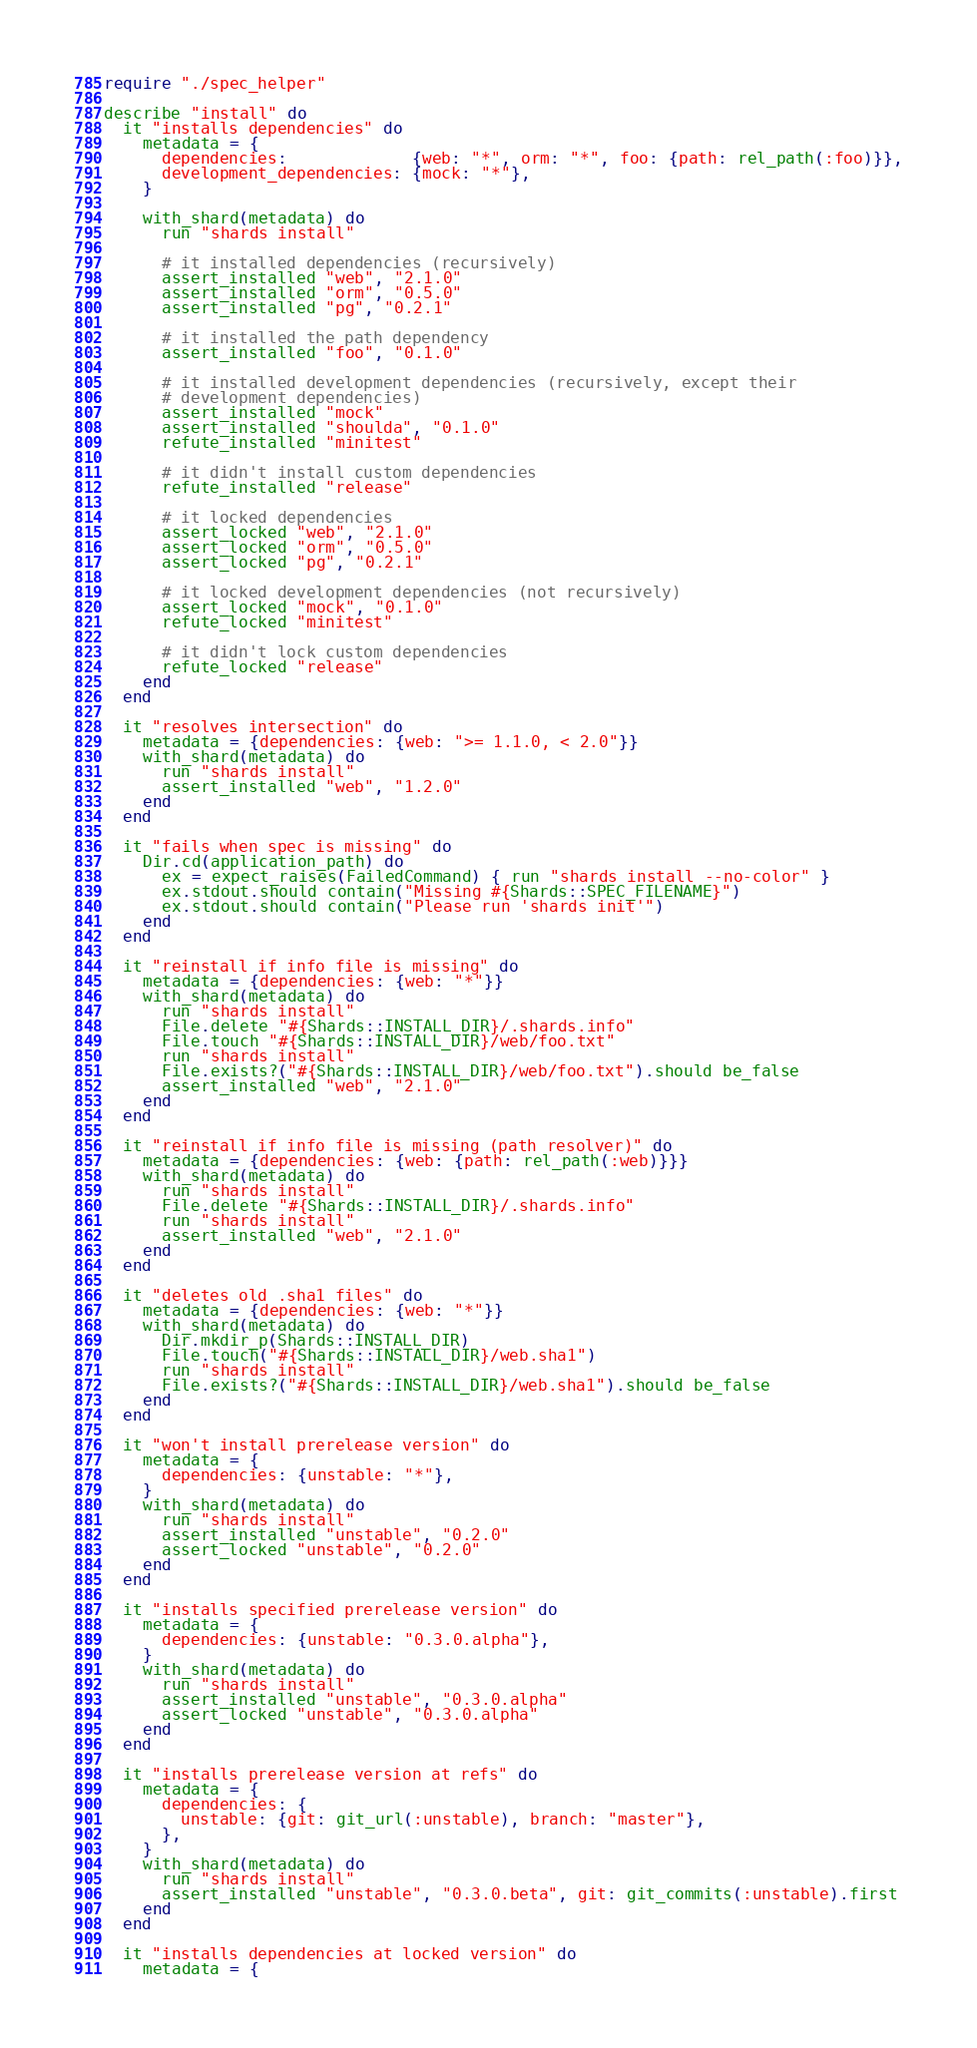<code> <loc_0><loc_0><loc_500><loc_500><_Crystal_>require "./spec_helper"

describe "install" do
  it "installs dependencies" do
    metadata = {
      dependencies:             {web: "*", orm: "*", foo: {path: rel_path(:foo)}},
      development_dependencies: {mock: "*"},
    }

    with_shard(metadata) do
      run "shards install"

      # it installed dependencies (recursively)
      assert_installed "web", "2.1.0"
      assert_installed "orm", "0.5.0"
      assert_installed "pg", "0.2.1"

      # it installed the path dependency
      assert_installed "foo", "0.1.0"

      # it installed development dependencies (recursively, except their
      # development dependencies)
      assert_installed "mock"
      assert_installed "shoulda", "0.1.0"
      refute_installed "minitest"

      # it didn't install custom dependencies
      refute_installed "release"

      # it locked dependencies
      assert_locked "web", "2.1.0"
      assert_locked "orm", "0.5.0"
      assert_locked "pg", "0.2.1"

      # it locked development dependencies (not recursively)
      assert_locked "mock", "0.1.0"
      refute_locked "minitest"

      # it didn't lock custom dependencies
      refute_locked "release"
    end
  end

  it "resolves intersection" do
    metadata = {dependencies: {web: ">= 1.1.0, < 2.0"}}
    with_shard(metadata) do
      run "shards install"
      assert_installed "web", "1.2.0"
    end
  end

  it "fails when spec is missing" do
    Dir.cd(application_path) do
      ex = expect_raises(FailedCommand) { run "shards install --no-color" }
      ex.stdout.should contain("Missing #{Shards::SPEC_FILENAME}")
      ex.stdout.should contain("Please run 'shards init'")
    end
  end

  it "reinstall if info file is missing" do
    metadata = {dependencies: {web: "*"}}
    with_shard(metadata) do
      run "shards install"
      File.delete "#{Shards::INSTALL_DIR}/.shards.info"
      File.touch "#{Shards::INSTALL_DIR}/web/foo.txt"
      run "shards install"
      File.exists?("#{Shards::INSTALL_DIR}/web/foo.txt").should be_false
      assert_installed "web", "2.1.0"
    end
  end

  it "reinstall if info file is missing (path resolver)" do
    metadata = {dependencies: {web: {path: rel_path(:web)}}}
    with_shard(metadata) do
      run "shards install"
      File.delete "#{Shards::INSTALL_DIR}/.shards.info"
      run "shards install"
      assert_installed "web", "2.1.0"
    end
  end

  it "deletes old .sha1 files" do
    metadata = {dependencies: {web: "*"}}
    with_shard(metadata) do
      Dir.mkdir_p(Shards::INSTALL_DIR)
      File.touch("#{Shards::INSTALL_DIR}/web.sha1")
      run "shards install"
      File.exists?("#{Shards::INSTALL_DIR}/web.sha1").should be_false
    end
  end

  it "won't install prerelease version" do
    metadata = {
      dependencies: {unstable: "*"},
    }
    with_shard(metadata) do
      run "shards install"
      assert_installed "unstable", "0.2.0"
      assert_locked "unstable", "0.2.0"
    end
  end

  it "installs specified prerelease version" do
    metadata = {
      dependencies: {unstable: "0.3.0.alpha"},
    }
    with_shard(metadata) do
      run "shards install"
      assert_installed "unstable", "0.3.0.alpha"
      assert_locked "unstable", "0.3.0.alpha"
    end
  end

  it "installs prerelease version at refs" do
    metadata = {
      dependencies: {
        unstable: {git: git_url(:unstable), branch: "master"},
      },
    }
    with_shard(metadata) do
      run "shards install"
      assert_installed "unstable", "0.3.0.beta", git: git_commits(:unstable).first
    end
  end

  it "installs dependencies at locked version" do
    metadata = {</code> 